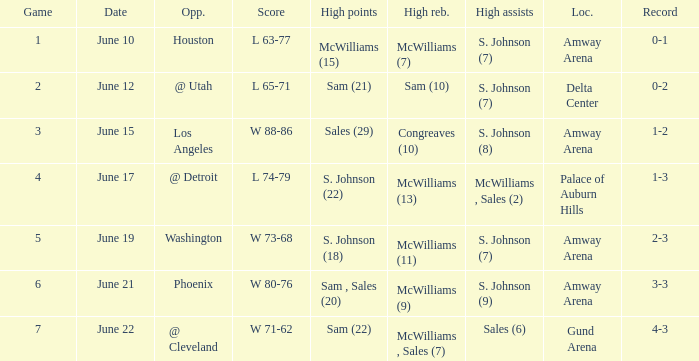Name the opponent for june 12 @ Utah. 